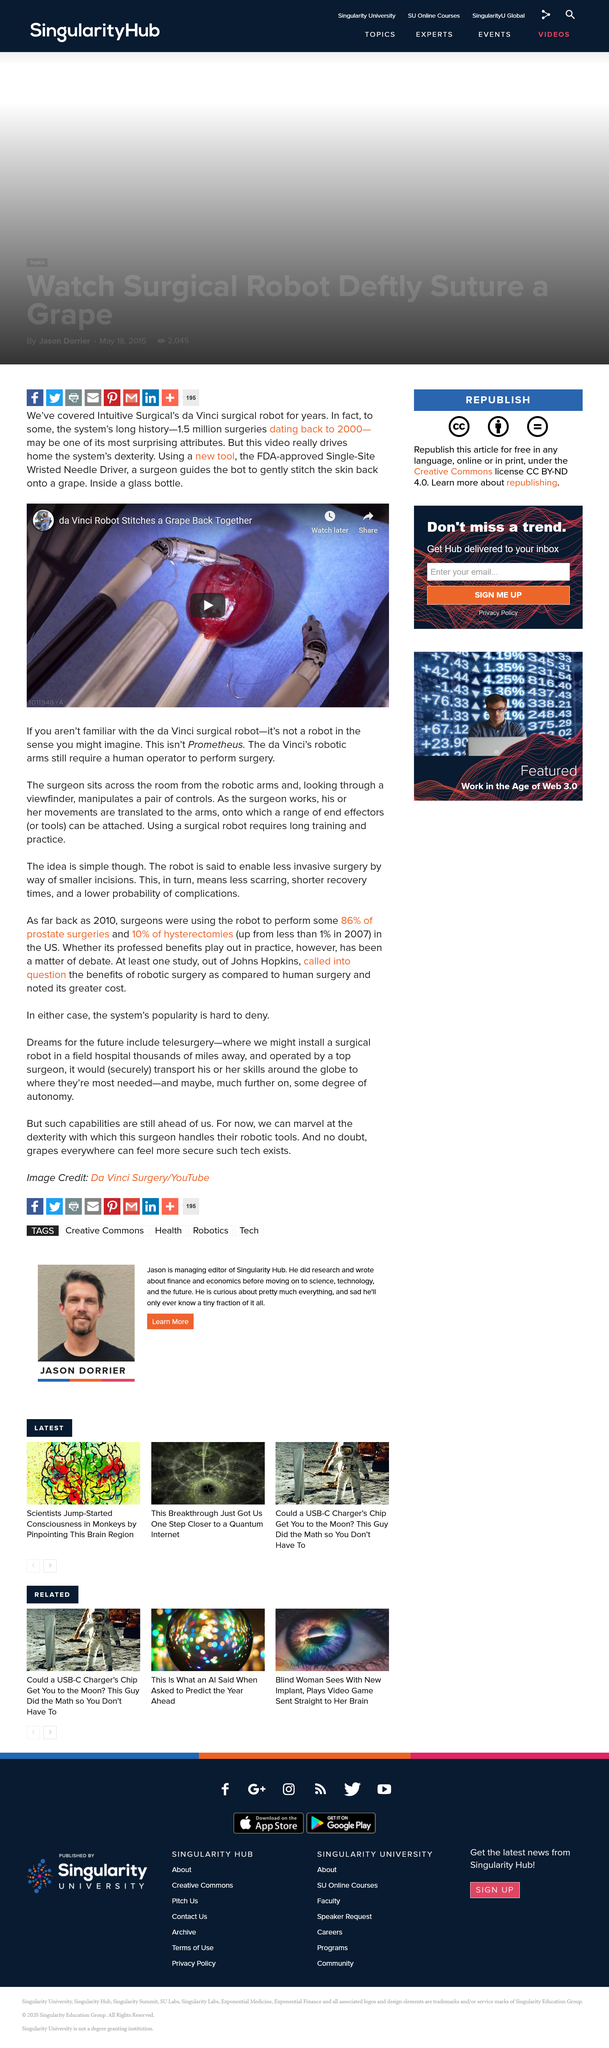Mention a couple of crucial points in this snapshot. The da Vinci robot is designed and used specifically for surgical procedures. The video depicts the use of the da Vinci robot. The da Vinci robot requires a human operator to function. 